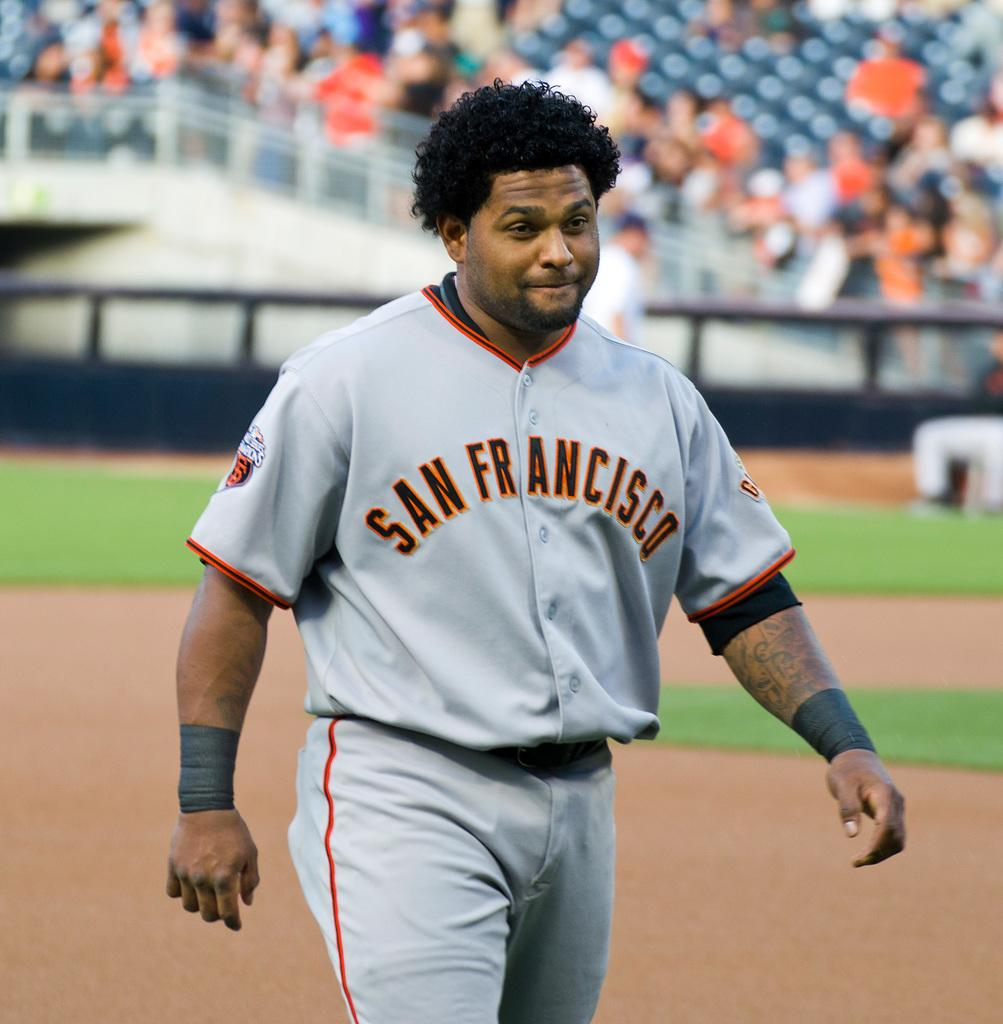Provide a one-sentence caption for the provided image. A baseball player wearing a grey strip with San Francisco on the front of his top walks on the baseball field. 